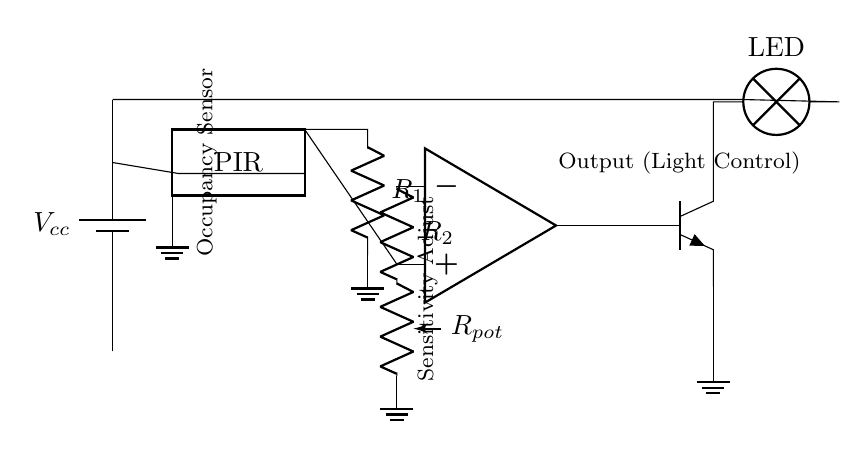What type of sensor is used in this circuit? The circuit diagram indicates a PIR (Passive Infrared) sensor, which is typically used for detecting occupancy through infrared radiation emitted by moving bodies.
Answer: PIR What does the adjustable component labeled as "R pot" control? The component labeled as "R pot" is a variable resistor or potentiometer, which allows for adjusting the sensitivity of the occupancy sensor to detect motion.
Answer: Sensitivity How many pins does the PIR sensor have? The PIR sensor in the diagram shows three pins, as denoted by the drawing of the dip chip.
Answer: Three What is the purpose of the op-amp in this circuit? The op-amp acts as a comparator to process the output from the PIR sensor and control the light based on occupancy detection and sensitivity settings.
Answer: Comparator What happens to the LED when motion is detected? When the PIR sensor detects motion, the op-amp turns on the transistor, allowing current to flow through to the LED, which illuminates in response.
Answer: Illuminates What is the role of R1 in this circuit? R1 is a resistor connected to the output of the PIR sensor, helping to limit the current and protect downstream components such as the op-amp and transistor.
Answer: Current limiting How does the circuit indicate that a space is unoccupied? When no motion is detected by the PIR, the op-amp output remains low, causing the transistor to remain off, which means the LED will be off, indicating that the space is unoccupied.
Answer: LED off 